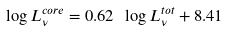Convert formula to latex. <formula><loc_0><loc_0><loc_500><loc_500>\log L ^ { c o r e } _ { \nu } = 0 . 6 2 \ \log L ^ { t o t } _ { \nu } + 8 . 4 1</formula> 